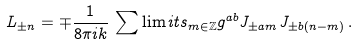<formula> <loc_0><loc_0><loc_500><loc_500>L _ { \pm n } = \mp \frac { 1 } { 8 \pi i k } \, \sum \lim i t s _ { m \in \mathbb { Z } } g ^ { a b } J _ { \pm a m } J _ { \pm b \left ( n - m \right ) } \, .</formula> 